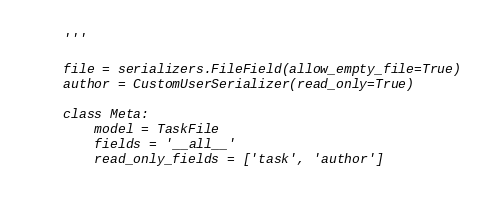<code> <loc_0><loc_0><loc_500><loc_500><_Python_>    '''

    file = serializers.FileField(allow_empty_file=True)
    author = CustomUserSerializer(read_only=True)

    class Meta:
        model = TaskFile
        fields = '__all__'
        read_only_fields = ['task', 'author']
</code> 